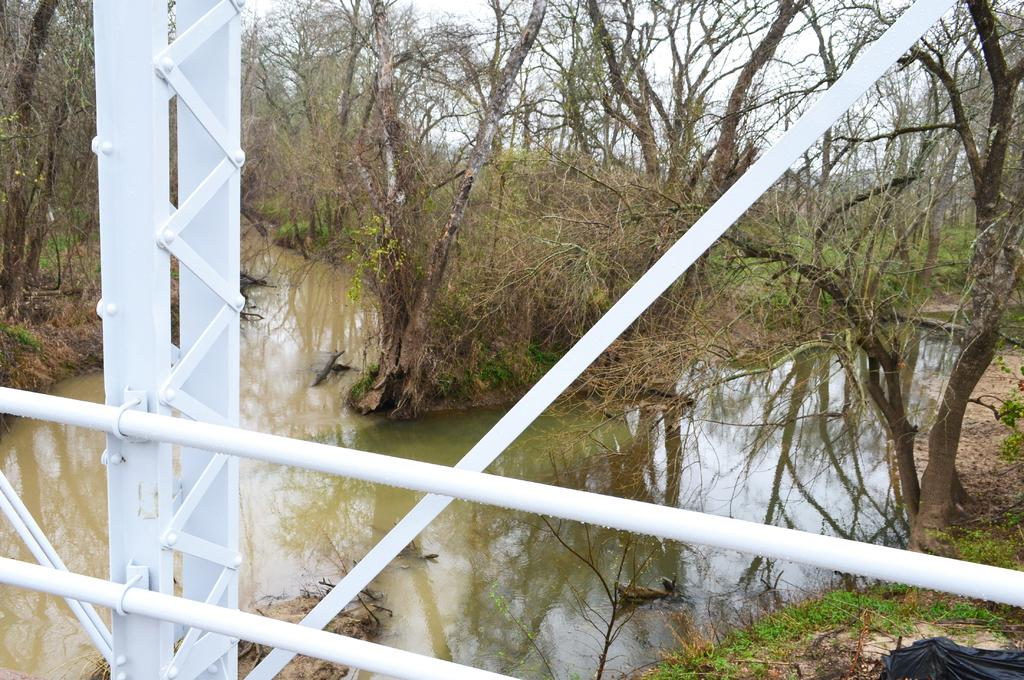What is the main structure visible in the foreground of the image? There is a white railing of a bridge in the foreground of the image. What can be seen flowing in the background of the image? A river is flowing down to the bridge in the background of the image. What type of vegetation is visible in the background of the image? There are trees visible in the background of the image. What part of the natural environment is visible in the background of the image? The sky is visible in the background of the image. How many wings can be seen on the bridge in the image? There are no wings present on the bridge in the image. What time of day is it in the image, considering the visibility of the sky? The time of day cannot be determined from the visibility of the sky alone in the image. 